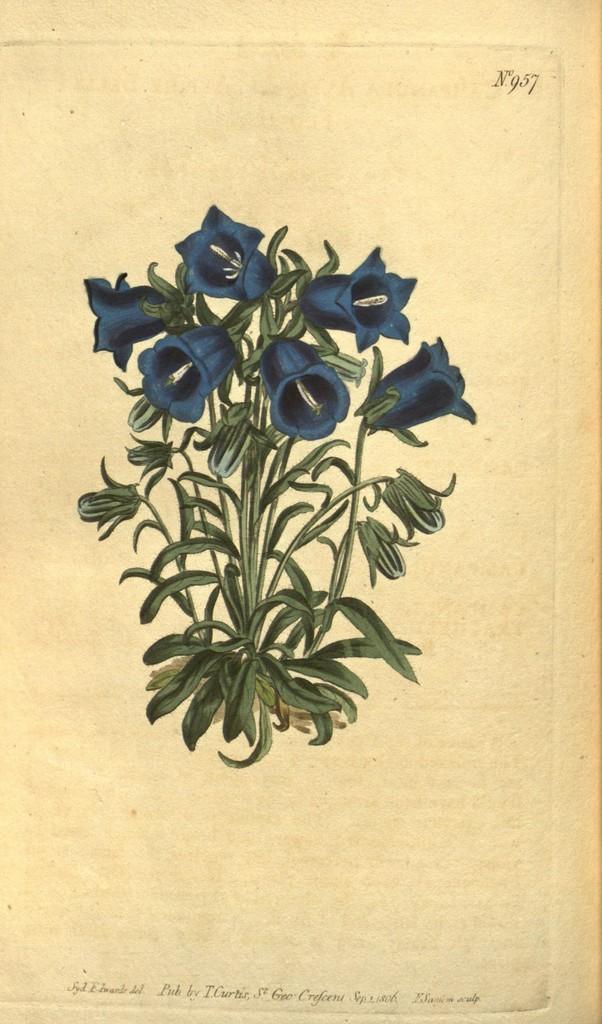Please provide a concise description of this image. In this image, we can see a painting of a plant along with flowers. 